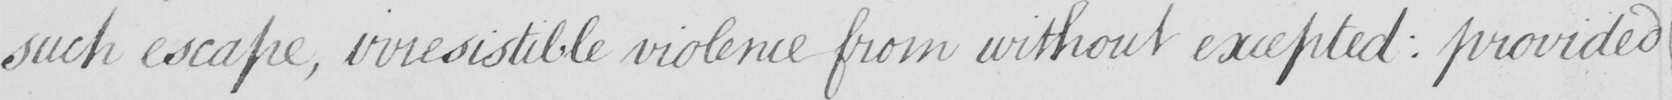Please provide the text content of this handwritten line. such escape , irresistible violence from without excepted :  provided 